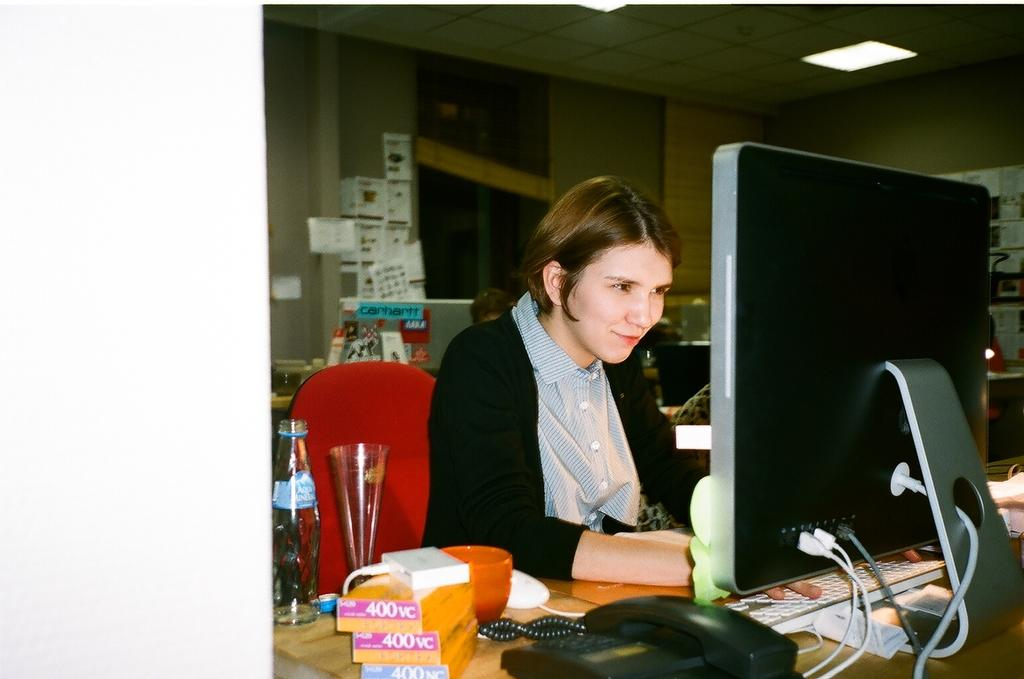What type of furniture is present in the image? There is a chair and a table in the image. What is the woman in the image doing? The woman is sitting on the chair. What electronic device is visible in the image? There is a laptop in the image. What other objects can be seen on the table? There is a telephone, boxes, bowls, and glasses on the table. Is there a volcano erupting in the background of the image? No, there is no volcano present in the image. What type of brass instrument is being played by the woman in the image? There is no brass instrument present in the image; the woman is sitting on a chair and there is a laptop in front of her. 